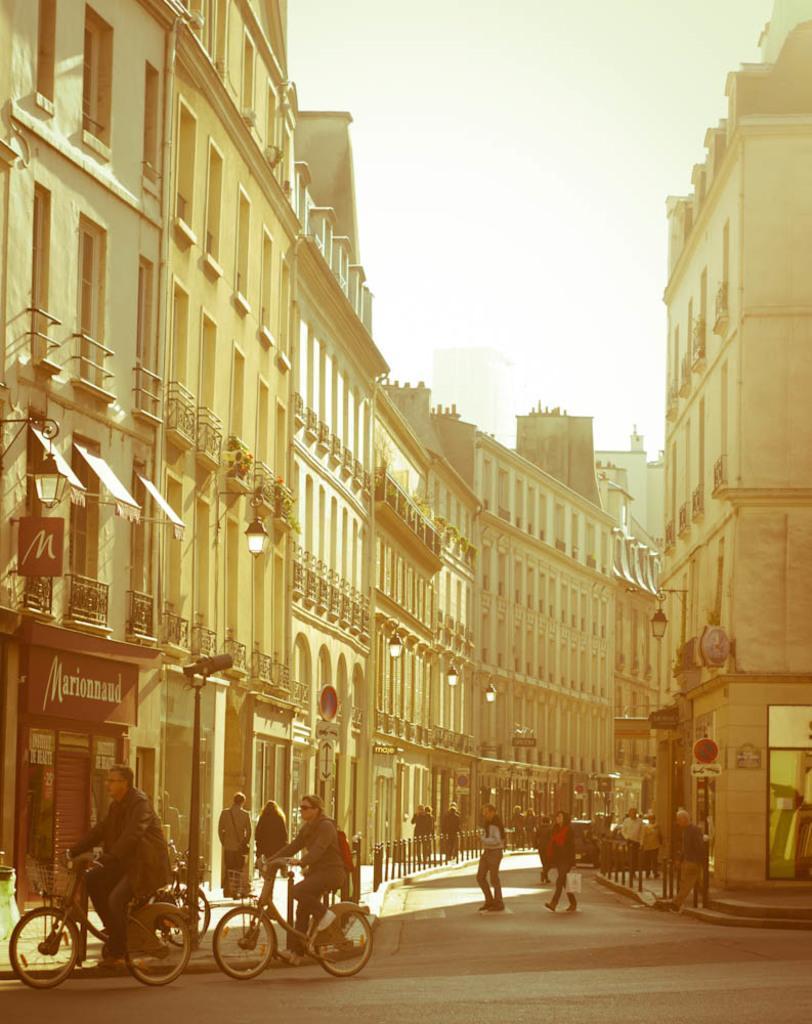Could you give a brief overview of what you see in this image? This is a picture of out side of a city and right side there is a building and left side there is a another building ,there is a sky visible and there are the people riding on the bi cycle visible on the right side ,on the middle where are the persons walking on the road. 